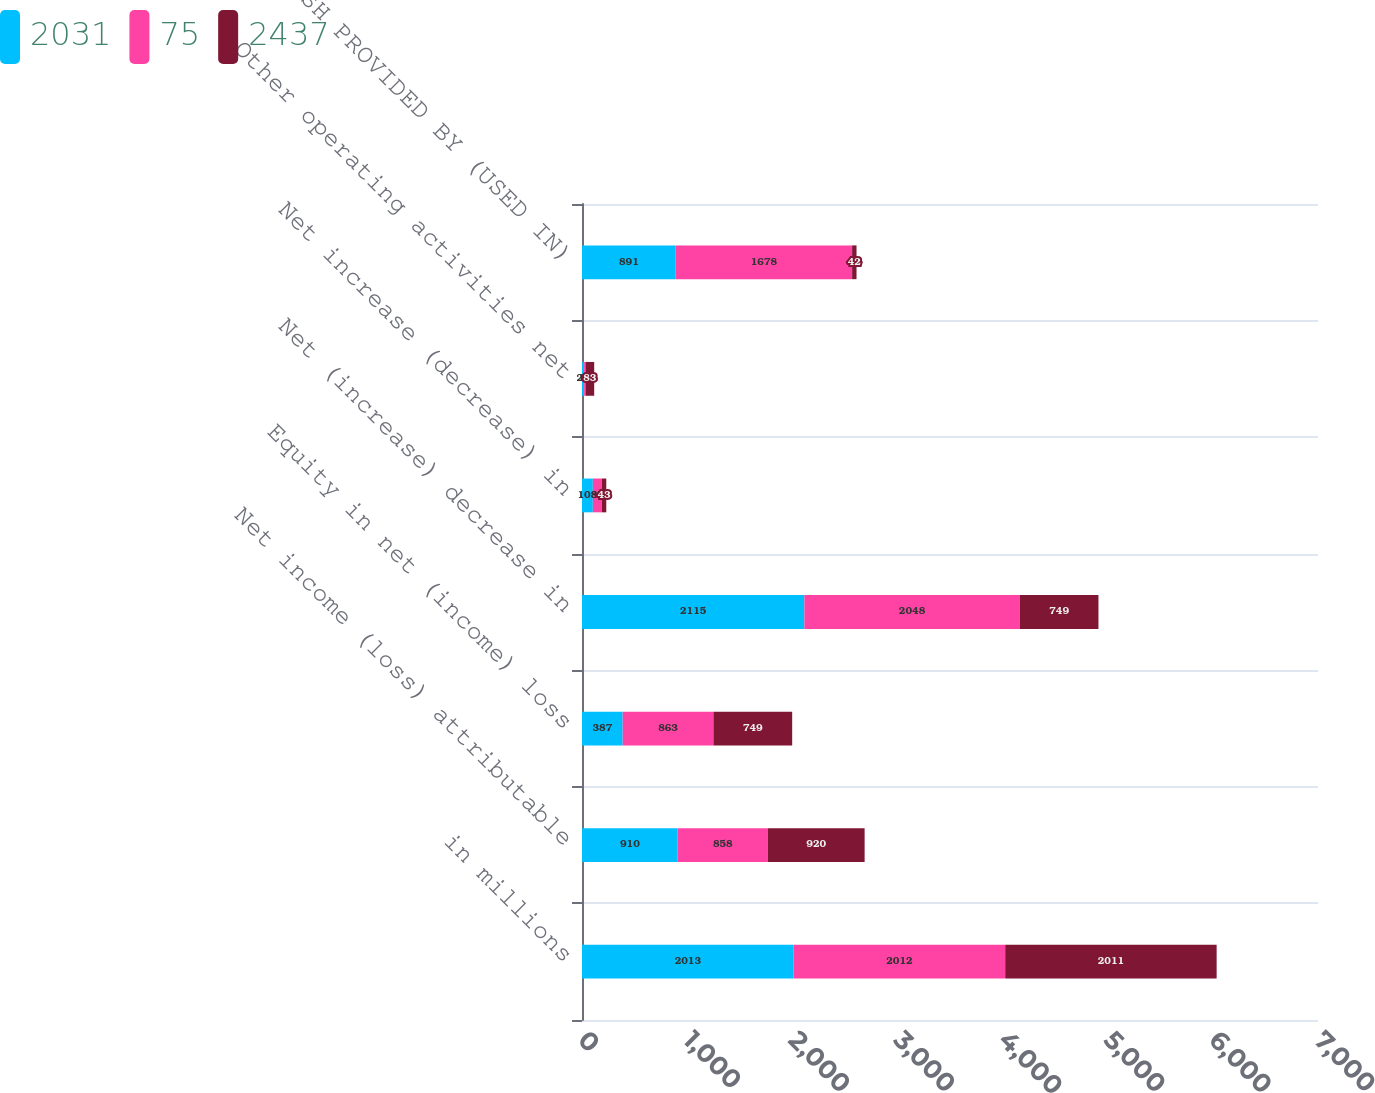<chart> <loc_0><loc_0><loc_500><loc_500><stacked_bar_chart><ecel><fcel>in millions<fcel>Net income (loss) attributable<fcel>Equity in net (income) loss<fcel>Net (increase) decrease in<fcel>Net increase (decrease) in<fcel>Other operating activities net<fcel>NET CASH PROVIDED BY (USED IN)<nl><fcel>2031<fcel>2013<fcel>910<fcel>387<fcel>2115<fcel>103<fcel>20<fcel>891<nl><fcel>75<fcel>2012<fcel>858<fcel>863<fcel>2048<fcel>85<fcel>13<fcel>1678<nl><fcel>2437<fcel>2011<fcel>920<fcel>749<fcel>749<fcel>43<fcel>83<fcel>42<nl></chart> 